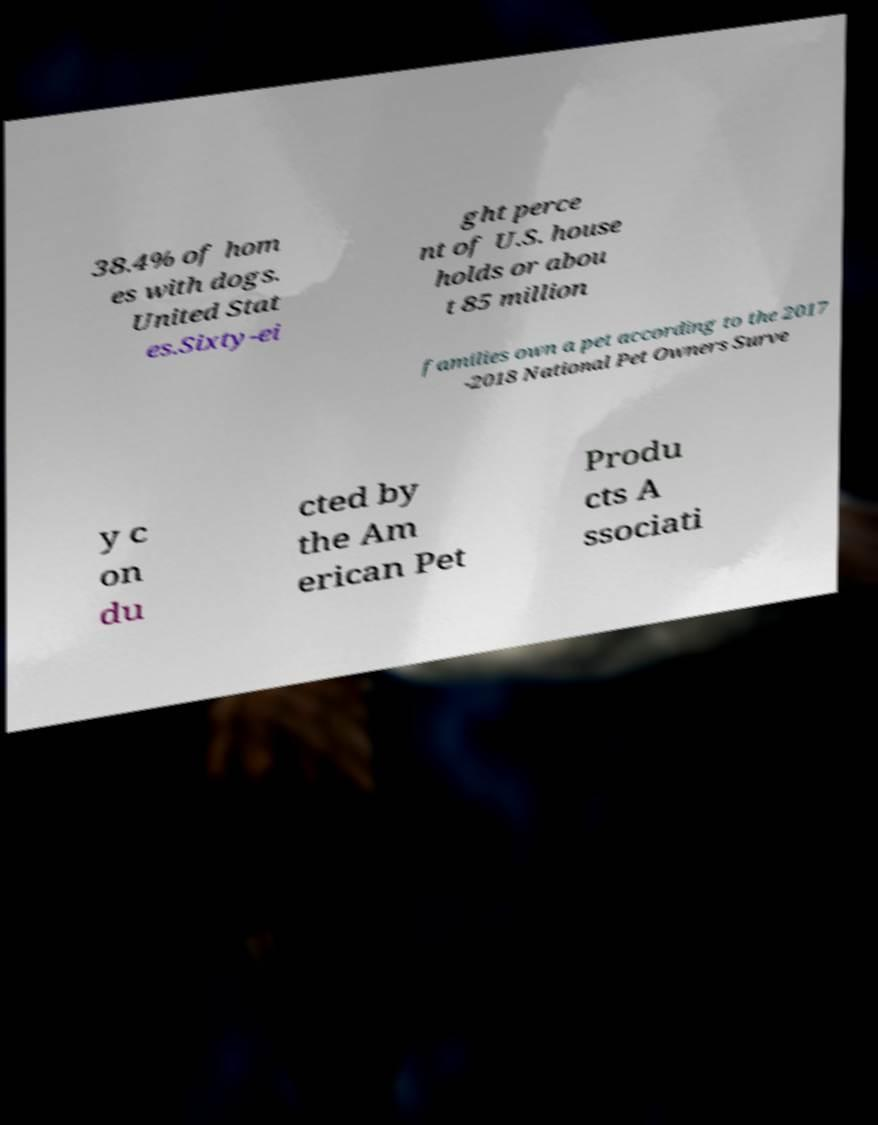I need the written content from this picture converted into text. Can you do that? 38.4% of hom es with dogs. United Stat es.Sixty-ei ght perce nt of U.S. house holds or abou t 85 million families own a pet according to the 2017 -2018 National Pet Owners Surve y c on du cted by the Am erican Pet Produ cts A ssociati 